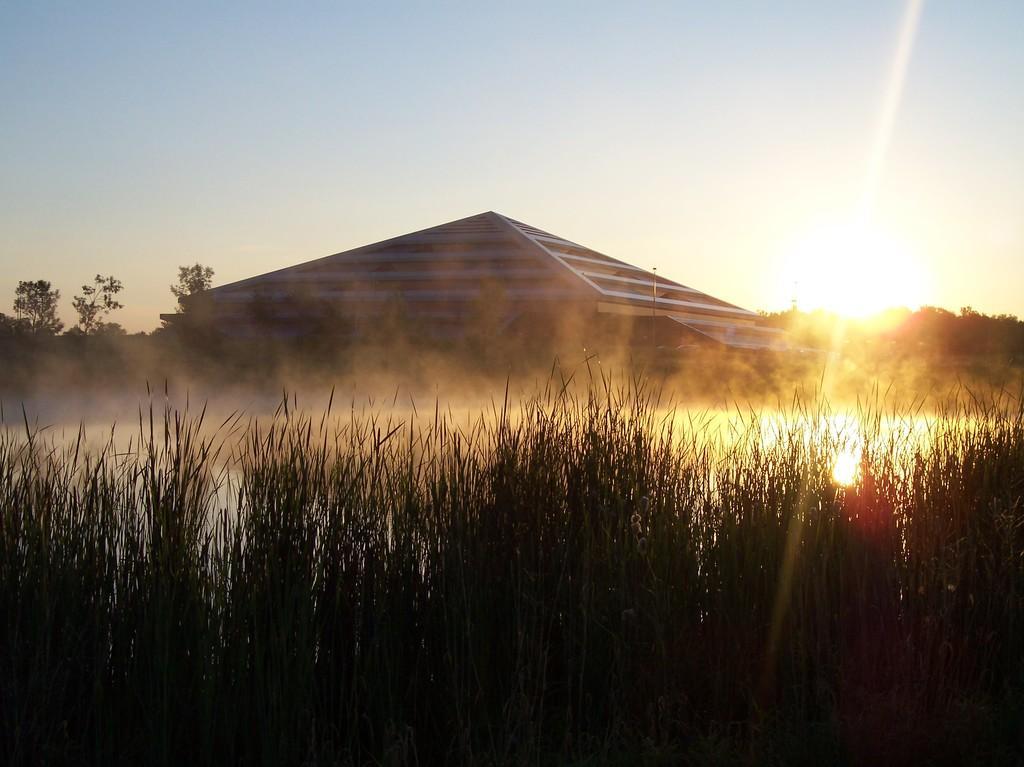Could you give a brief overview of what you see in this image? In the center of the image there is a building. At the bottom of the image we can see water and plants. In the background there are trees and sky. 